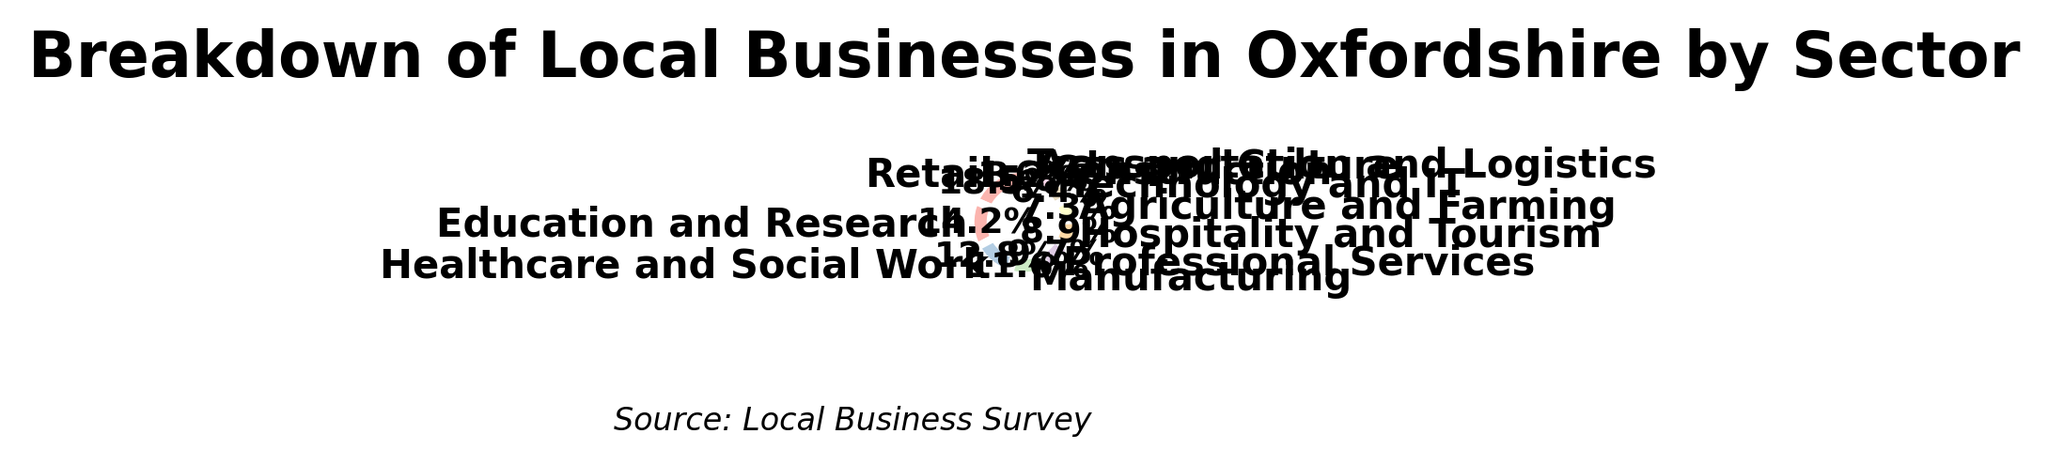What percentage of businesses in Oxfordshire belong to the top three sectors? The top three sectors are Retail (18.5%), Education and Research (14.2%), and Healthcare and Social Work (12.8%). Adding these percentages together: 18.5 + 14.2 + 12.8 = 45.5.
Answer: 45.5% Which sector has the smallest percentage of businesses, and what is that percentage? The sector with the smallest percentage is Transportation and Logistics with a percentage of 1.6%.
Answer: Transportation and Logistics, 1.6% How much greater is the percentage of Retail businesses compared to Arts and Culture businesses? The percentage of Retail businesses is 18.5%, and that of Arts and Culture is 3.2%. Subtracting these values: 18.5 - 3.2 = 15.3.
Answer: 15.3% Are there more businesses in Professional Services or Technology and IT, and what is the difference in percentage? Professional Services have 9.7%, and Technology and IT have 6.4%. Subtract the smaller percentage from the larger: 9.7 - 6.4 = 3.3.
Answer: Professional Services, 3.3% What is the combined percentage of businesses in Healthcare and Social Work, and Agriculture and Farming? The percentage for Healthcare and Social Work is 12.8%, and Agriculture and Farming is 7.3%. Adding these values together: 12.8 + 7.3 = 20.1.
Answer: 20.1% How do the percentages of Manufacturing and Construction compare? Manufacturing has 11.6%, while Construction has 5.8%. Manufacturing has a higher percentage.
Answer: Manufacturing is greater Which sectors have a percentage below 10%, and what are those percentages? Sectors below 10% are: Hospitality and Tourism (8.9%), Agriculture and Farming (7.3%), Technology and IT (6.4%), Construction (5.8%), Arts and Culture (3.2%), and Transportation and Logistics (1.6%).
Answer: Hospitality and Tourism (8.9%), Agriculture and Farming (7.3%), Technology and IT (6.4%), Construction (5.8%), Arts and Culture (3.2%), Transportation and Logistics (1.6%) What is the average percentage of the four smallest sectors? The four smallest sectors are: Technology and IT (6.4%), Construction (5.8%), Arts and Culture (3.2%), and Transportation and Logistics (1.6%). Adding these percentages together: 6.4 + 5.8 + 3.2 + 1.6 = 17. Then divide by 4: 17 / 4 = 4.25.
Answer: 4.25% Arrange the following sectors in ascending order of their percentages: Healthcare and Social Work, Manufacturing, Professional Services, Arts and Culture. Their percentages are: Arts and Culture (3.2%), Professional Services (9.7%), Healthcare and Social Work (12.8%), Manufacturing (11.6%). Ascending order is: Arts and Culture (3.2%), Professional Services (9.7%), Manufacturing (11.6%), Healthcare and Social Work (12.8%).
Answer: Arts and Culture, Professional Services, Manufacturing, Healthcare and Social Work Is the percentage of businesses in Education and Research more than double that in Technology and IT? The percentage of Education and Research businesses is 14.2%, and that of Technology and IT is 6.4%. Doubling the percentage of Technology and IT: 6.4 * 2 = 12.8%. 14.2% is indeed more than 12.8%.
Answer: Yes 